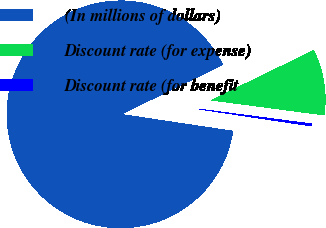<chart> <loc_0><loc_0><loc_500><loc_500><pie_chart><fcel>(In millions of dollars)<fcel>Discount rate (for expense)<fcel>Discount rate (for benefit<nl><fcel>90.43%<fcel>9.29%<fcel>0.28%<nl></chart> 